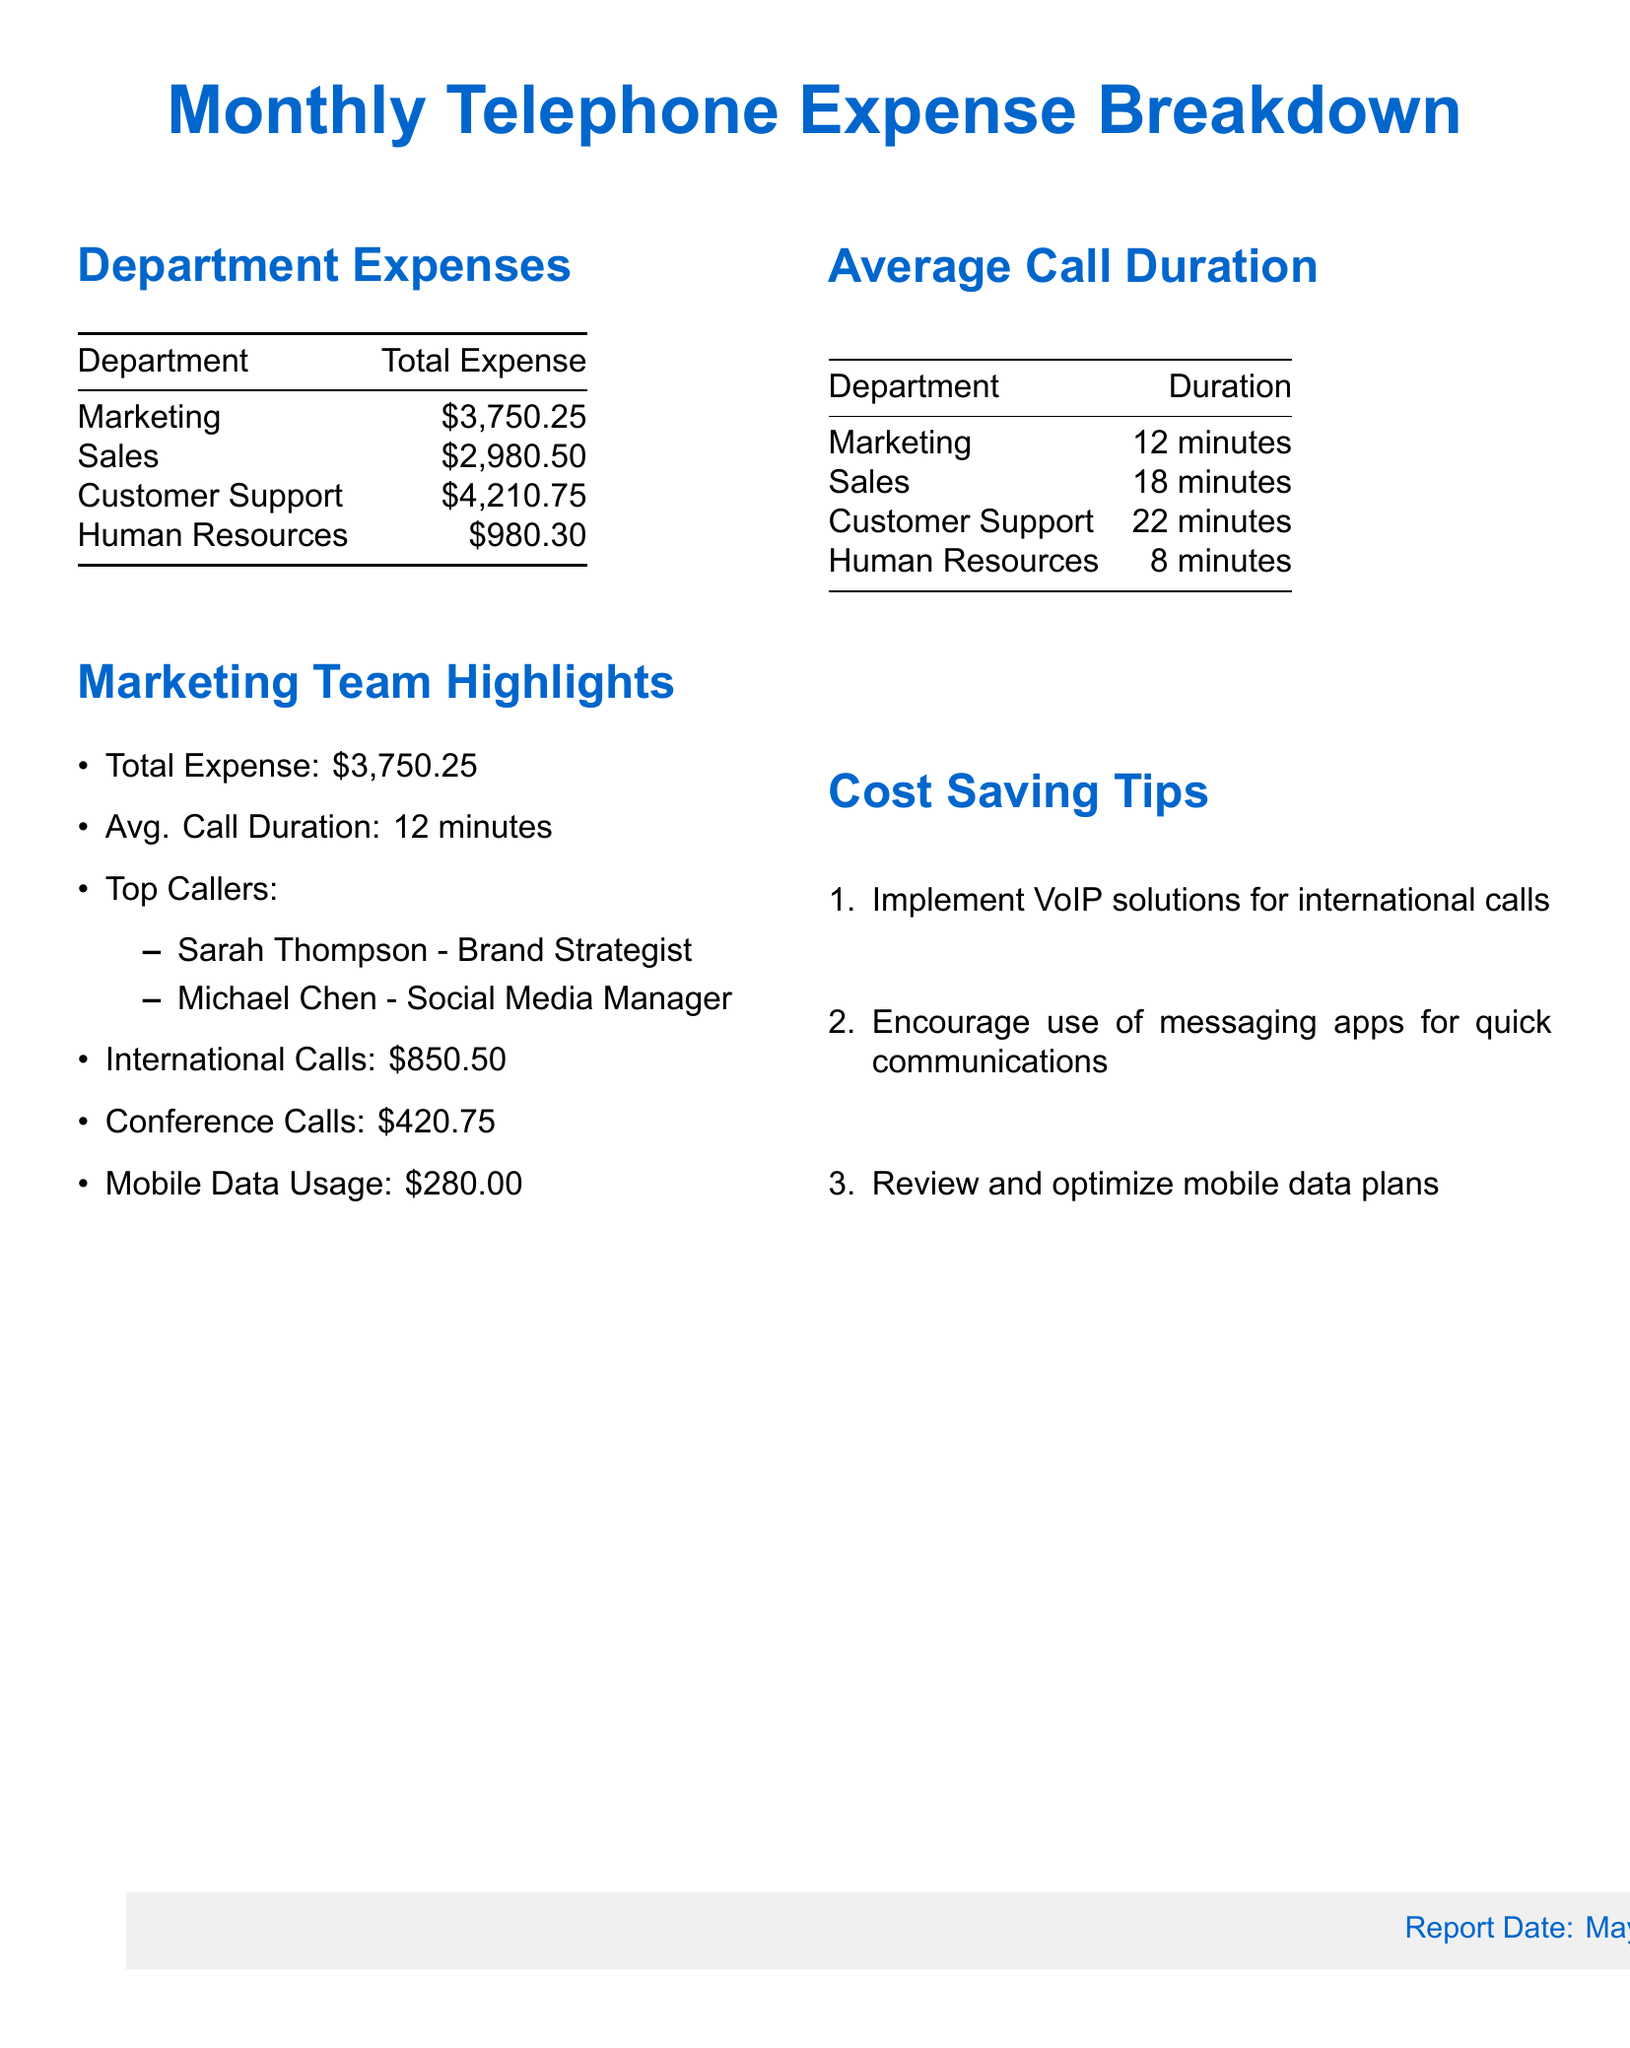What is the total expense for the Marketing department? The total expense for the Marketing department is listed in the document under Department Expenses.
Answer: $3,750.25 What was the average call duration for the Marketing team? The average call duration for the Marketing team is detailed in the Average Call Duration section.
Answer: 12 minutes Who is the top caller from the Marketing team? The document lists the top callers in the Marketing Team Highlights section.
Answer: Sarah Thompson What is the total amount spent on international calls by the Marketing team? The total amount spent on international calls is stated in the Marketing Team Highlights.
Answer: $850.50 What is the expense for Customer Support? The expense for Customer Support can be found in the Department Expenses table.
Answer: $4,210.75 What cost-saving tip involves using messaging apps? One of the cost-saving tips suggests an alternative to traditional calls for quick communications.
Answer: Encourage use of messaging apps What is the total telephone expense for Sales? The total telephone expense for Sales is provided in the Department Expenses section.
Answer: $2,980.50 What other department has the highest average call duration? To identify this, compare the average call durations listed in the Average Call Duration table.
Answer: Customer Support What is the report date mentioned in the document? The report date is located in the footer of the document.
Answer: May 2023 